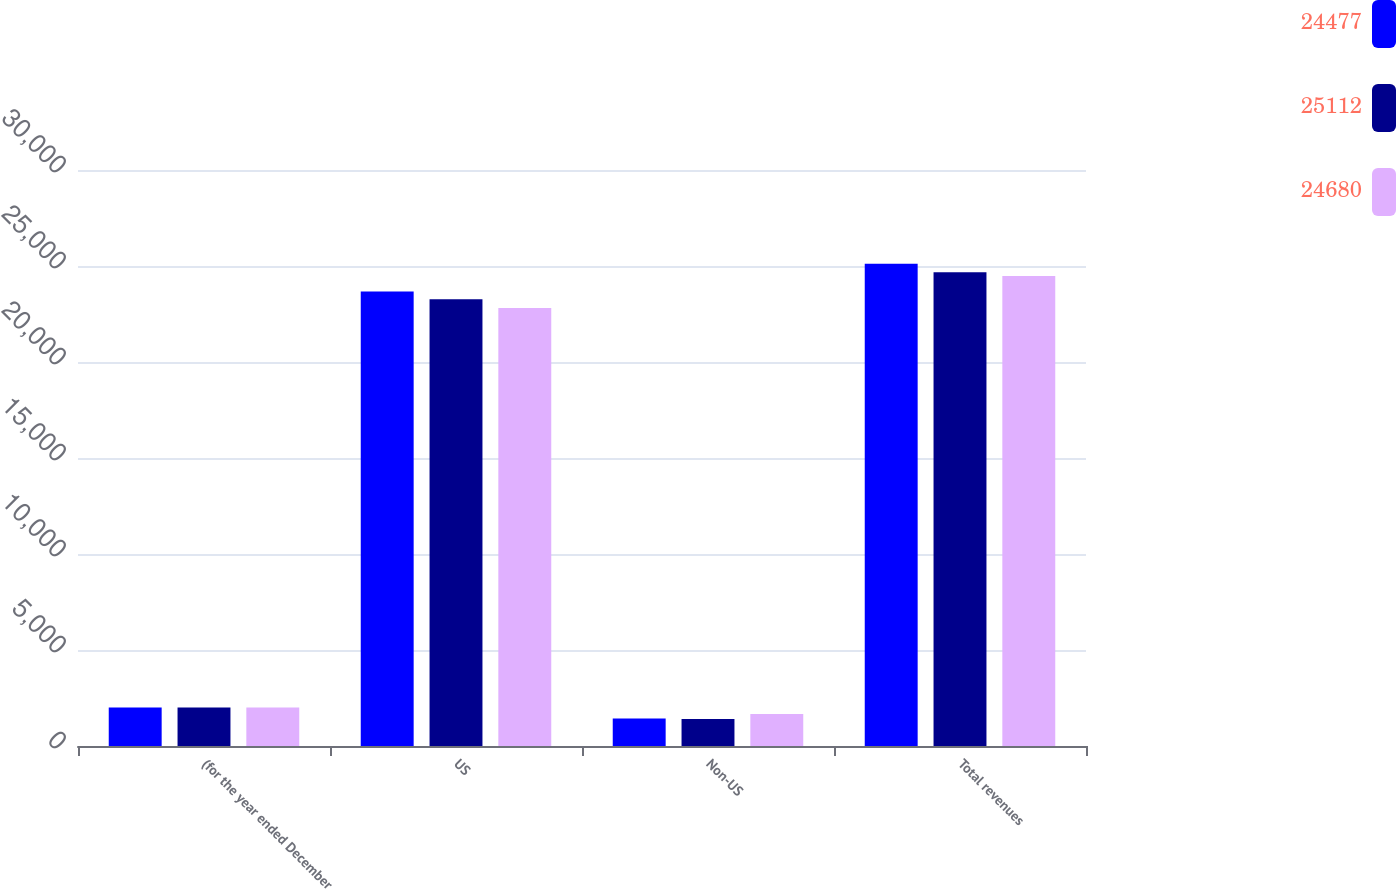<chart> <loc_0><loc_0><loc_500><loc_500><stacked_bar_chart><ecel><fcel>(for the year ended December<fcel>US<fcel>Non-US<fcel>Total revenues<nl><fcel>24477<fcel>2010<fcel>23677<fcel>1435<fcel>25112<nl><fcel>25112<fcel>2009<fcel>23271<fcel>1409<fcel>24680<nl><fcel>24680<fcel>2008<fcel>22809<fcel>1668<fcel>24477<nl></chart> 